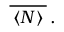Convert formula to latex. <formula><loc_0><loc_0><loc_500><loc_500>\, \overline { \, \langle N \rangle \, } \, . \,</formula> 